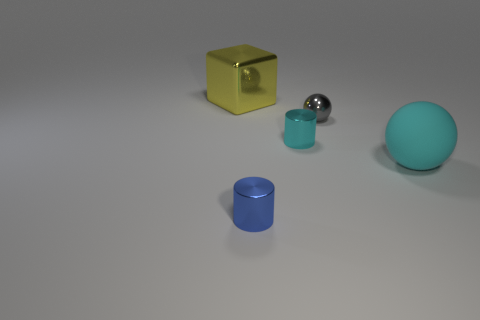Add 3 big yellow cubes. How many objects exist? 8 Subtract all cyan cylinders. How many cylinders are left? 1 Subtract all cylinders. How many objects are left? 3 Subtract all tiny red objects. Subtract all cubes. How many objects are left? 4 Add 5 big yellow things. How many big yellow things are left? 6 Add 2 gray things. How many gray things exist? 3 Subtract 0 yellow balls. How many objects are left? 5 Subtract 1 spheres. How many spheres are left? 1 Subtract all purple cylinders. Subtract all cyan blocks. How many cylinders are left? 2 Subtract all blue blocks. How many gray balls are left? 1 